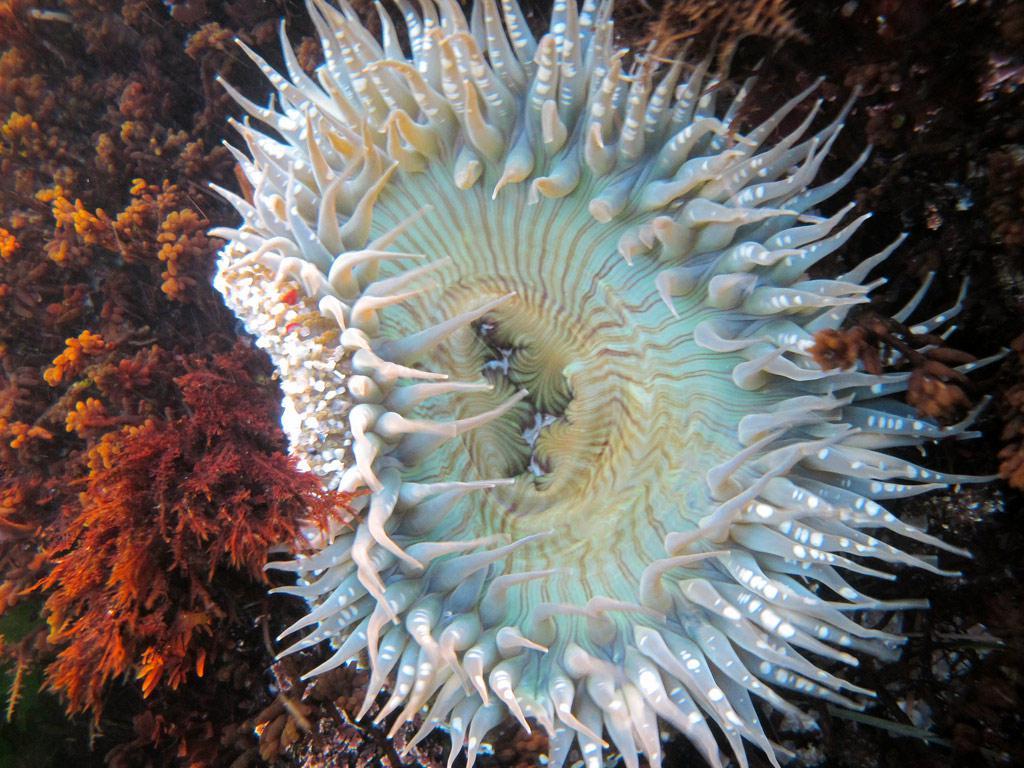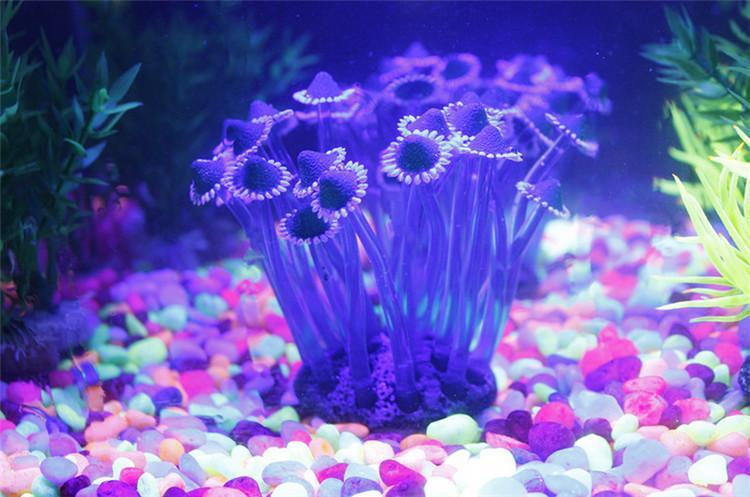The first image is the image on the left, the second image is the image on the right. Examine the images to the left and right. Is the description "There are red stones on the sea floor." accurate? Answer yes or no. Yes. 